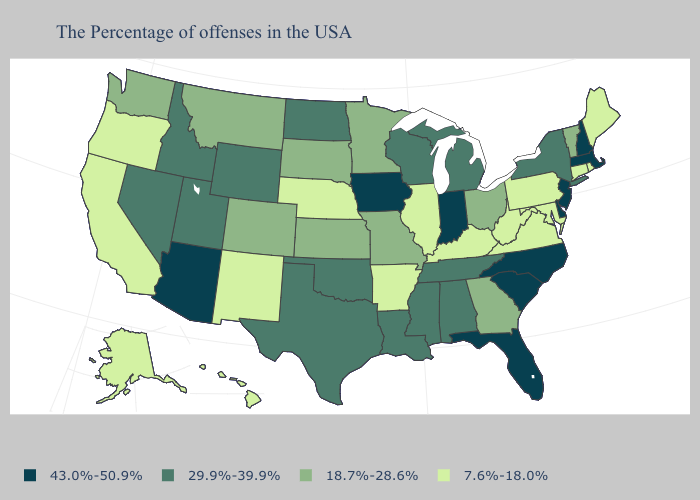Does Indiana have the highest value in the USA?
Be succinct. Yes. What is the lowest value in the MidWest?
Be succinct. 7.6%-18.0%. What is the value of New Hampshire?
Quick response, please. 43.0%-50.9%. Does Arizona have the highest value in the USA?
Give a very brief answer. Yes. What is the highest value in the MidWest ?
Keep it brief. 43.0%-50.9%. Name the states that have a value in the range 7.6%-18.0%?
Keep it brief. Maine, Rhode Island, Connecticut, Maryland, Pennsylvania, Virginia, West Virginia, Kentucky, Illinois, Arkansas, Nebraska, New Mexico, California, Oregon, Alaska, Hawaii. Which states hav the highest value in the MidWest?
Answer briefly. Indiana, Iowa. Does Nebraska have the same value as Alabama?
Short answer required. No. How many symbols are there in the legend?
Give a very brief answer. 4. What is the value of Florida?
Quick response, please. 43.0%-50.9%. Name the states that have a value in the range 29.9%-39.9%?
Give a very brief answer. New York, Michigan, Alabama, Tennessee, Wisconsin, Mississippi, Louisiana, Oklahoma, Texas, North Dakota, Wyoming, Utah, Idaho, Nevada. Does Illinois have the same value as Pennsylvania?
Quick response, please. Yes. Does Delaware have the highest value in the South?
Give a very brief answer. Yes. What is the value of Georgia?
Concise answer only. 18.7%-28.6%. What is the highest value in the West ?
Write a very short answer. 43.0%-50.9%. 